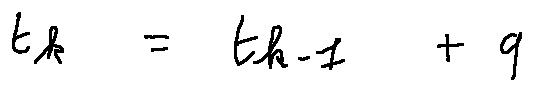<formula> <loc_0><loc_0><loc_500><loc_500>t _ { k } = t _ { k - 1 } + q</formula> 